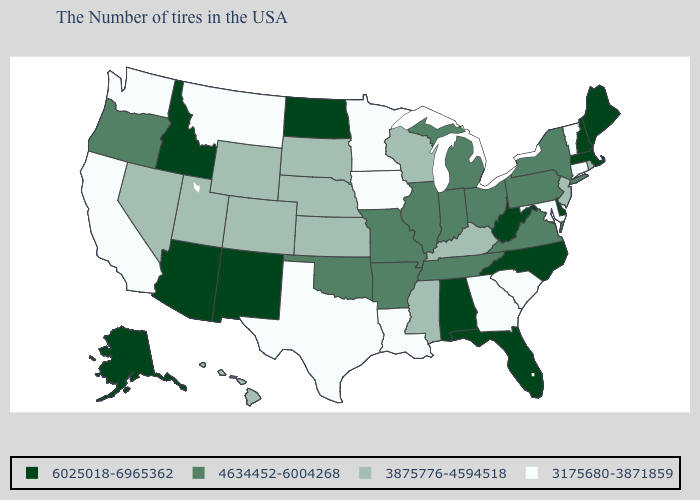Is the legend a continuous bar?
Concise answer only. No. Name the states that have a value in the range 3875776-4594518?
Keep it brief. Rhode Island, New Jersey, Kentucky, Wisconsin, Mississippi, Kansas, Nebraska, South Dakota, Wyoming, Colorado, Utah, Nevada, Hawaii. What is the value of Maryland?
Write a very short answer. 3175680-3871859. Name the states that have a value in the range 6025018-6965362?
Write a very short answer. Maine, Massachusetts, New Hampshire, Delaware, North Carolina, West Virginia, Florida, Alabama, North Dakota, New Mexico, Arizona, Idaho, Alaska. Does Arizona have the same value as Mississippi?
Keep it brief. No. What is the highest value in the USA?
Answer briefly. 6025018-6965362. What is the value of New Mexico?
Give a very brief answer. 6025018-6965362. Does North Dakota have the same value as Florida?
Concise answer only. Yes. What is the value of Montana?
Give a very brief answer. 3175680-3871859. Name the states that have a value in the range 3875776-4594518?
Concise answer only. Rhode Island, New Jersey, Kentucky, Wisconsin, Mississippi, Kansas, Nebraska, South Dakota, Wyoming, Colorado, Utah, Nevada, Hawaii. Among the states that border New Mexico , which have the lowest value?
Quick response, please. Texas. Does Nebraska have a lower value than Illinois?
Concise answer only. Yes. Name the states that have a value in the range 6025018-6965362?
Short answer required. Maine, Massachusetts, New Hampshire, Delaware, North Carolina, West Virginia, Florida, Alabama, North Dakota, New Mexico, Arizona, Idaho, Alaska. What is the value of Rhode Island?
Answer briefly. 3875776-4594518. Among the states that border Tennessee , does Kentucky have the highest value?
Write a very short answer. No. 